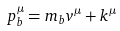Convert formula to latex. <formula><loc_0><loc_0><loc_500><loc_500>p _ { b } ^ { \mu } = m _ { b } v ^ { \mu } + k ^ { \mu }</formula> 